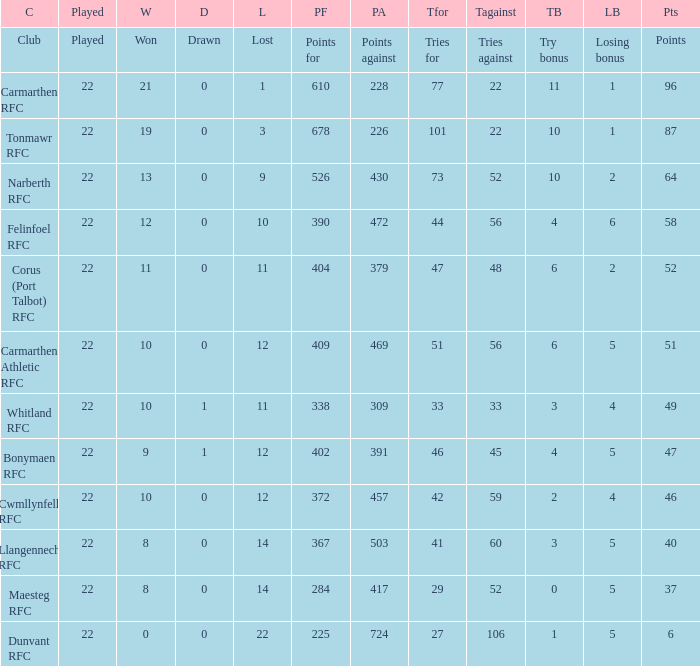Name the losing bonus of 96 points 1.0. 